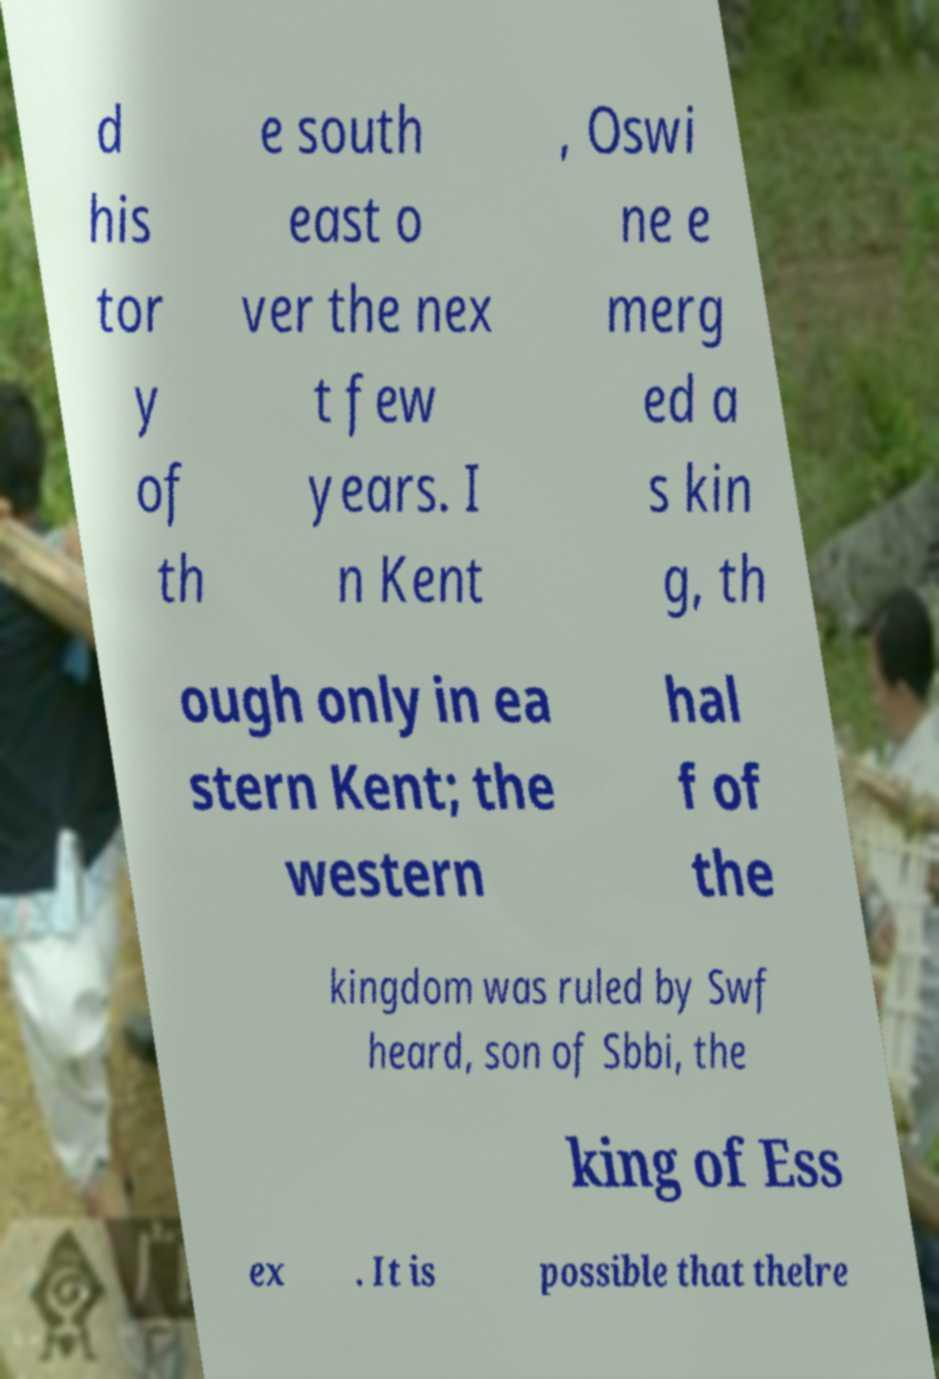Can you accurately transcribe the text from the provided image for me? d his tor y of th e south east o ver the nex t few years. I n Kent , Oswi ne e merg ed a s kin g, th ough only in ea stern Kent; the western hal f of the kingdom was ruled by Swf heard, son of Sbbi, the king of Ess ex . It is possible that thelre 